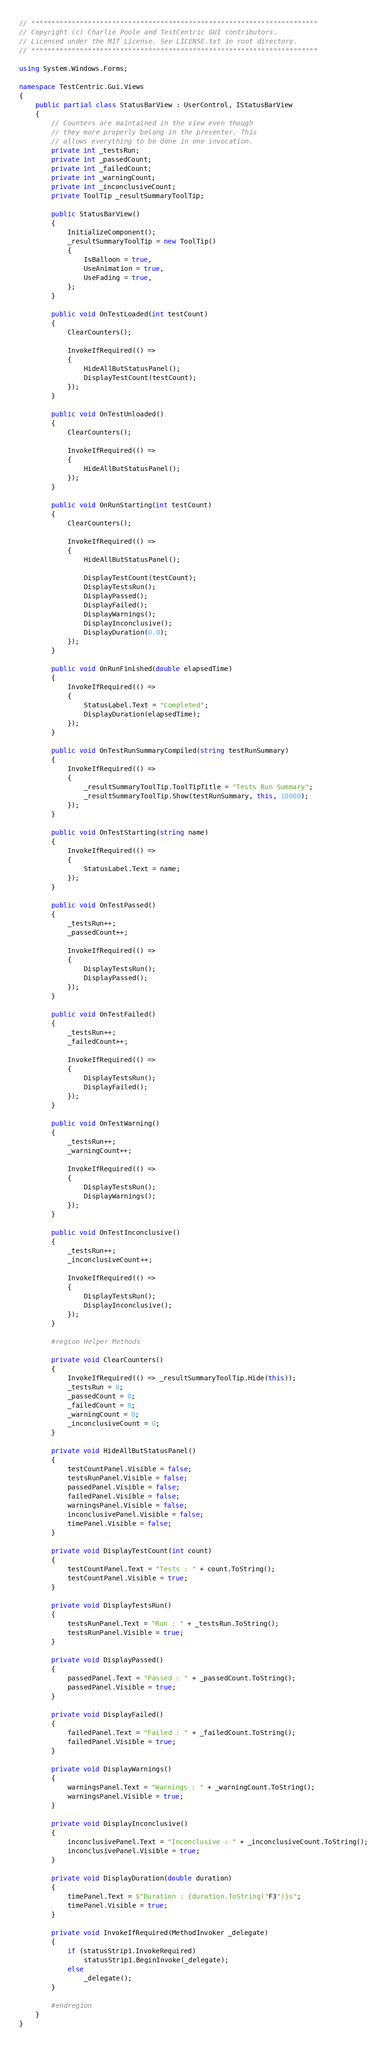Convert code to text. <code><loc_0><loc_0><loc_500><loc_500><_C#_>// ***********************************************************************
// Copyright (c) Charlie Poole and TestCentric GUI contributors.
// Licensed under the MIT License. See LICENSE.txt in root directory.
// ***********************************************************************

using System.Windows.Forms;

namespace TestCentric.Gui.Views
{
    public partial class StatusBarView : UserControl, IStatusBarView
    {
        // Counters are maintained in the view even though
        // they more properly belong in the presenter. This
        // allows everything to be done in one invocation.
        private int _testsRun;
        private int _passedCount;
        private int _failedCount;
        private int _warningCount;
        private int _inconclusiveCount;
        private ToolTip _resultSummaryToolTip;

        public StatusBarView()
        {
            InitializeComponent();
            _resultSummaryToolTip = new ToolTip()
            {
                IsBalloon = true,
                UseAnimation = true,
                UseFading = true,
            };
        }

        public void OnTestLoaded(int testCount)
        {
            ClearCounters();

            InvokeIfRequired(() =>
            {
                HideAllButStatusPanel();
                DisplayTestCount(testCount);
            });
        }

        public void OnTestUnloaded()
        {
            ClearCounters();

            InvokeIfRequired(() =>
            {
                HideAllButStatusPanel();
            });
        }

        public void OnRunStarting(int testCount)
        {
            ClearCounters();

            InvokeIfRequired(() =>
            {
                HideAllButStatusPanel();

                DisplayTestCount(testCount);
                DisplayTestsRun();
                DisplayPassed();
                DisplayFailed();
                DisplayWarnings();
                DisplayInconclusive();
                DisplayDuration(0.0);
            });
        }

        public void OnRunFinished(double elapsedTime)
        {
            InvokeIfRequired(() =>
            {
                StatusLabel.Text = "Completed";
                DisplayDuration(elapsedTime);
            });
        }

        public void OnTestRunSummaryCompiled(string testRunSummary)
        {
            InvokeIfRequired(() =>
            {
                _resultSummaryToolTip.ToolTipTitle = "Tests Run Summary";
                _resultSummaryToolTip.Show(testRunSummary, this, 10000);
            });
        }

        public void OnTestStarting(string name)
        {
            InvokeIfRequired(() =>
            {
                StatusLabel.Text = name;
            });
        }

        public void OnTestPassed()
        {
            _testsRun++;
            _passedCount++;

            InvokeIfRequired(() =>
            {
                DisplayTestsRun();
                DisplayPassed();
            });
        }

        public void OnTestFailed()
        {
            _testsRun++;
            _failedCount++;

            InvokeIfRequired(() =>
            {
                DisplayTestsRun();
                DisplayFailed();
            });
        }

        public void OnTestWarning()
        {
            _testsRun++;
            _warningCount++;

            InvokeIfRequired(() =>
            {
                DisplayTestsRun();
                DisplayWarnings();
            });
        }

        public void OnTestInconclusive()
        {
            _testsRun++;
            _inconclusiveCount++;

            InvokeIfRequired(() =>
            {
                DisplayTestsRun();
                DisplayInconclusive();
            });
        }

        #region Helper Methods

        private void ClearCounters()
        {
            InvokeIfRequired(() => _resultSummaryToolTip.Hide(this));
            _testsRun = 0;
            _passedCount = 0;
            _failedCount = 0;
            _warningCount = 0;
            _inconclusiveCount = 0;
        }

        private void HideAllButStatusPanel()
        {
            testCountPanel.Visible = false;
            testsRunPanel.Visible = false;
            passedPanel.Visible = false;
            failedPanel.Visible = false;
            warningsPanel.Visible = false;
            inconclusivePanel.Visible = false;
            timePanel.Visible = false;
        }

        private void DisplayTestCount(int count)
        {
            testCountPanel.Text = "Tests : " + count.ToString();
            testCountPanel.Visible = true;
        }

        private void DisplayTestsRun()
        {
            testsRunPanel.Text = "Run : " + _testsRun.ToString();
            testsRunPanel.Visible = true;
        }

        private void DisplayPassed()
        {
            passedPanel.Text = "Passed : " + _passedCount.ToString();
            passedPanel.Visible = true;
        }

        private void DisplayFailed()
        {
            failedPanel.Text = "Failed : " + _failedCount.ToString();
            failedPanel.Visible = true;
        }

        private void DisplayWarnings()
        {
            warningsPanel.Text = "Warnings : " + _warningCount.ToString();
            warningsPanel.Visible = true;
        }

        private void DisplayInconclusive()
        {
            inconclusivePanel.Text = "Inconclusive : " + _inconclusiveCount.ToString();
            inconclusivePanel.Visible = true;
        }

        private void DisplayDuration(double duration)
        {
            timePanel.Text = $"Duration : {duration.ToString("F3")}s";
            timePanel.Visible = true;
        }

        private void InvokeIfRequired(MethodInvoker _delegate)
        {
            if (statusStrip1.InvokeRequired)
                statusStrip1.BeginInvoke(_delegate);
            else
                _delegate();
        }

        #endregion
    }
}
</code> 